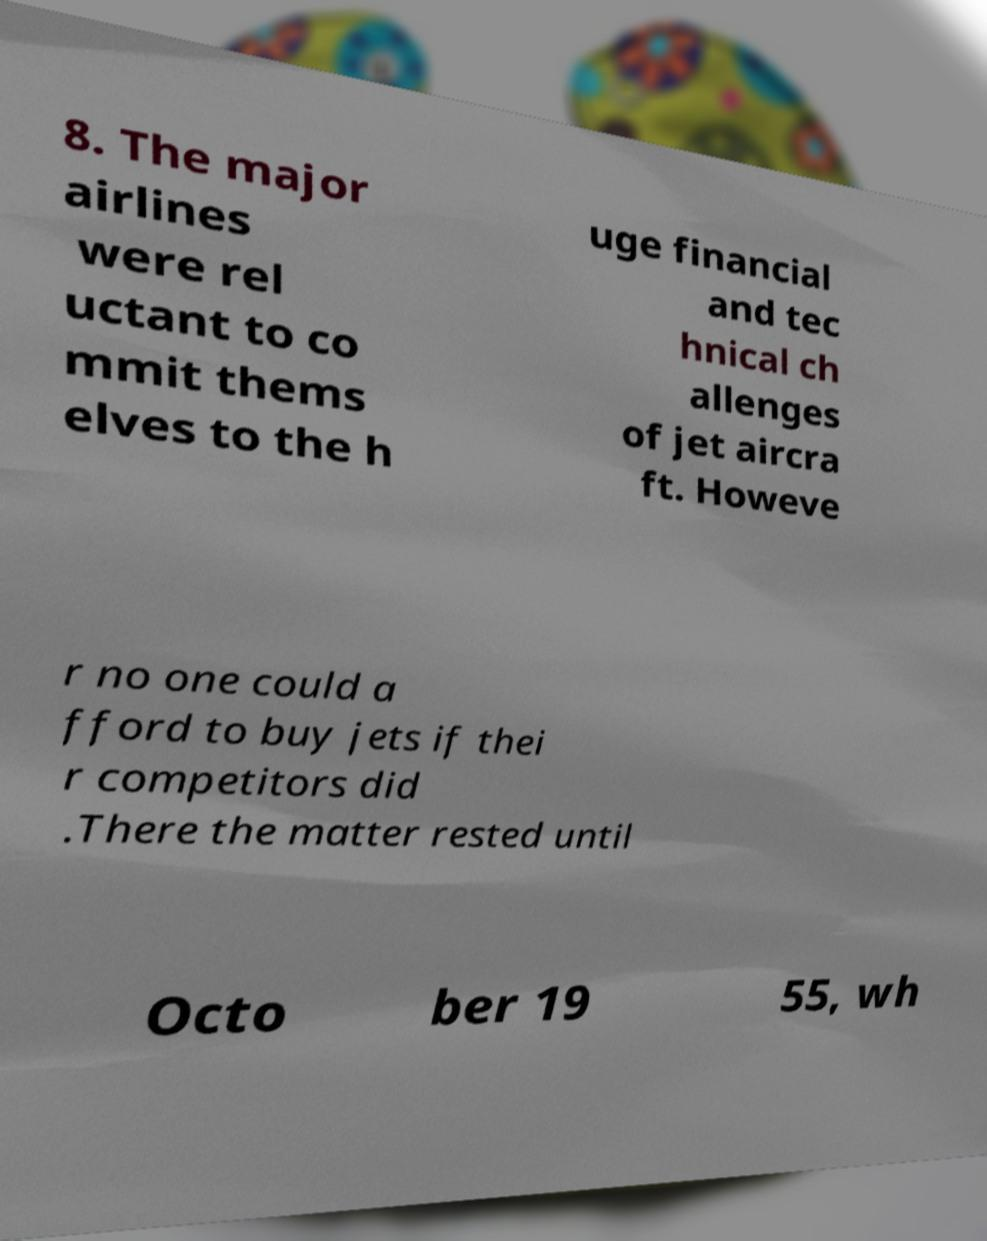Can you read and provide the text displayed in the image?This photo seems to have some interesting text. Can you extract and type it out for me? 8. The major airlines were rel uctant to co mmit thems elves to the h uge financial and tec hnical ch allenges of jet aircra ft. Howeve r no one could a fford to buy jets if thei r competitors did .There the matter rested until Octo ber 19 55, wh 